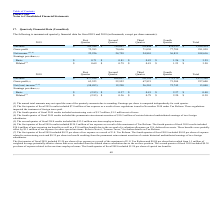According to Plexus's financial document, What was the net sales in the first quarter? According to the financial document, 765,544 (in thousands). The relevant text states: "Net sales $ 765,544 $ 789,051 $ 799,644 $ 810,195 $ 3,164,434..." Also, What was the gross profit in the Third quarter? According to the financial document, 71,030 (in thousands). The relevant text states: "Gross profit 72,383 70,636 71,030 77,789 291,838..." Also, What was the total net income? According to the financial document, 108,616 (in thousands). The relevant text states: "Net income (2,3,4) 22,226 24,758 24,801 36,831 108,616..." Also, How many quarters did net sales exceed $800,000 thousand? Based on the analysis, there are 1 instances. The counting process: Fourth Quarter. Also, can you calculate: What was the change in the gross profit between the first and second quarter? Based on the calculation: 70,636-72,383, the result is -1747 (in thousands). This is based on the information: "Gross profit 72,383 70,636 71,030 77,789 291,838 Gross profit 72,383 70,636 71,030 77,789 291,838..." The key data points involved are: 70,636, 72,383. Also, can you calculate: What was the percentage change in the basic earnings per share between the third and fourth quarter? To answer this question, I need to perform calculations using the financial data. The calculation is: (1.26-0.83)/0.83, which equals 51.81 (percentage). This is based on the information: "Basic $ 0.71 $ 0.81 $ 0.83 $ 1.26 $ 3.59 Basic $ 0.71 $ 0.81 $ 0.83 $ 1.26 $ 3.59..." The key data points involved are: 0.83, 1.26. 